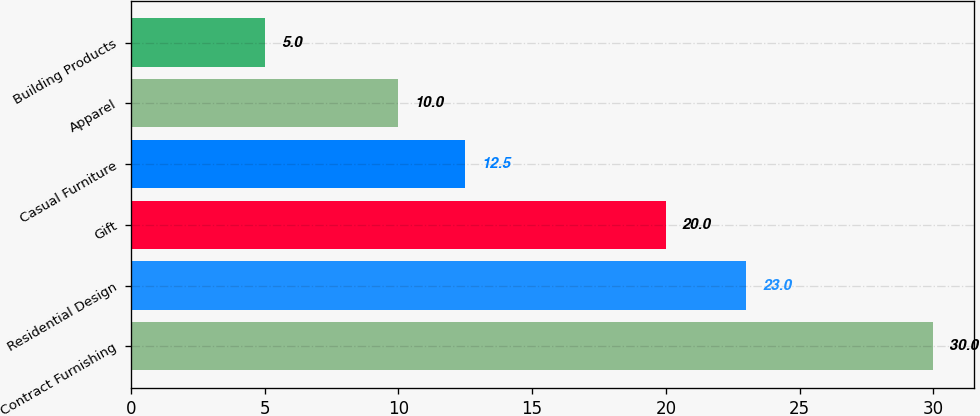<chart> <loc_0><loc_0><loc_500><loc_500><bar_chart><fcel>Contract Furnishing<fcel>Residential Design<fcel>Gift<fcel>Casual Furniture<fcel>Apparel<fcel>Building Products<nl><fcel>30<fcel>23<fcel>20<fcel>12.5<fcel>10<fcel>5<nl></chart> 